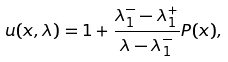Convert formula to latex. <formula><loc_0><loc_0><loc_500><loc_500>u ( x , \lambda ) = 1 + { \frac { \lambda _ { 1 } ^ { - } - \lambda _ { 1 } ^ { + } } { \lambda - \lambda _ { 1 } ^ { - } } } P ( x ) ,</formula> 